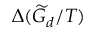Convert formula to latex. <formula><loc_0><loc_0><loc_500><loc_500>\Delta ( \widetilde { G } _ { d } / T )</formula> 